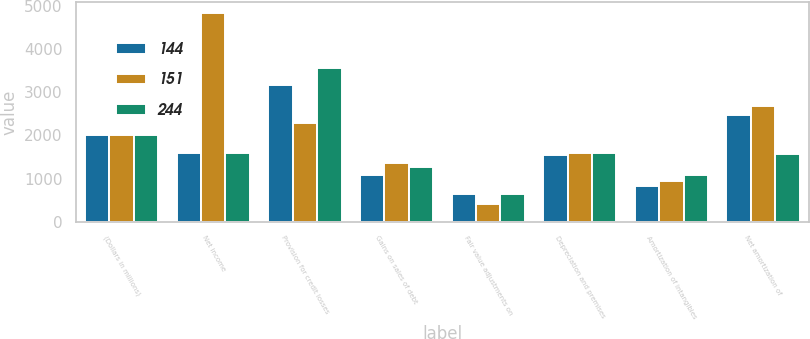Convert chart. <chart><loc_0><loc_0><loc_500><loc_500><stacked_bar_chart><ecel><fcel>(Dollars in millions)<fcel>Net income<fcel>Provision for credit losses<fcel>Gains on sales of debt<fcel>Fair value adjustments on<fcel>Depreciation and premises<fcel>Amortization of intangibles<fcel>Net amortization of<nl><fcel>144<fcel>2015<fcel>1581.5<fcel>3161<fcel>1091<fcel>633<fcel>1555<fcel>834<fcel>2472<nl><fcel>151<fcel>2014<fcel>4833<fcel>2275<fcel>1354<fcel>407<fcel>1586<fcel>936<fcel>2688<nl><fcel>244<fcel>2013<fcel>1581.5<fcel>3556<fcel>1271<fcel>649<fcel>1597<fcel>1086<fcel>1577<nl></chart> 